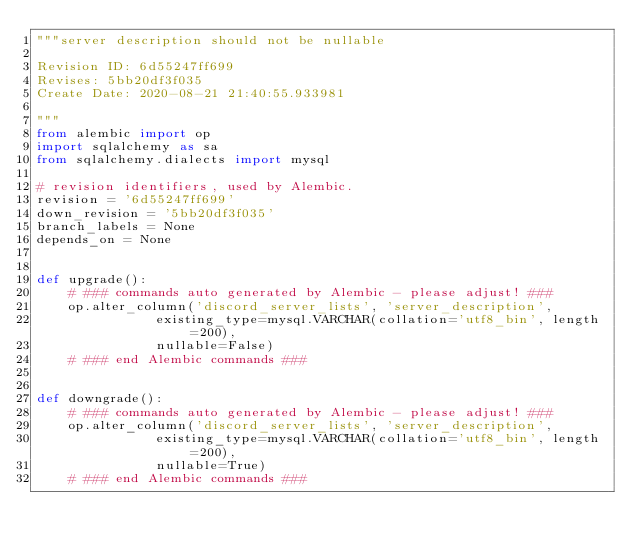Convert code to text. <code><loc_0><loc_0><loc_500><loc_500><_Python_>"""server description should not be nullable

Revision ID: 6d55247ff699
Revises: 5bb20df3f035
Create Date: 2020-08-21 21:40:55.933981

"""
from alembic import op
import sqlalchemy as sa
from sqlalchemy.dialects import mysql

# revision identifiers, used by Alembic.
revision = '6d55247ff699'
down_revision = '5bb20df3f035'
branch_labels = None
depends_on = None


def upgrade():
    # ### commands auto generated by Alembic - please adjust! ###
    op.alter_column('discord_server_lists', 'server_description',
               existing_type=mysql.VARCHAR(collation='utf8_bin', length=200),
               nullable=False)
    # ### end Alembic commands ###


def downgrade():
    # ### commands auto generated by Alembic - please adjust! ###
    op.alter_column('discord_server_lists', 'server_description',
               existing_type=mysql.VARCHAR(collation='utf8_bin', length=200),
               nullable=True)
    # ### end Alembic commands ###
</code> 